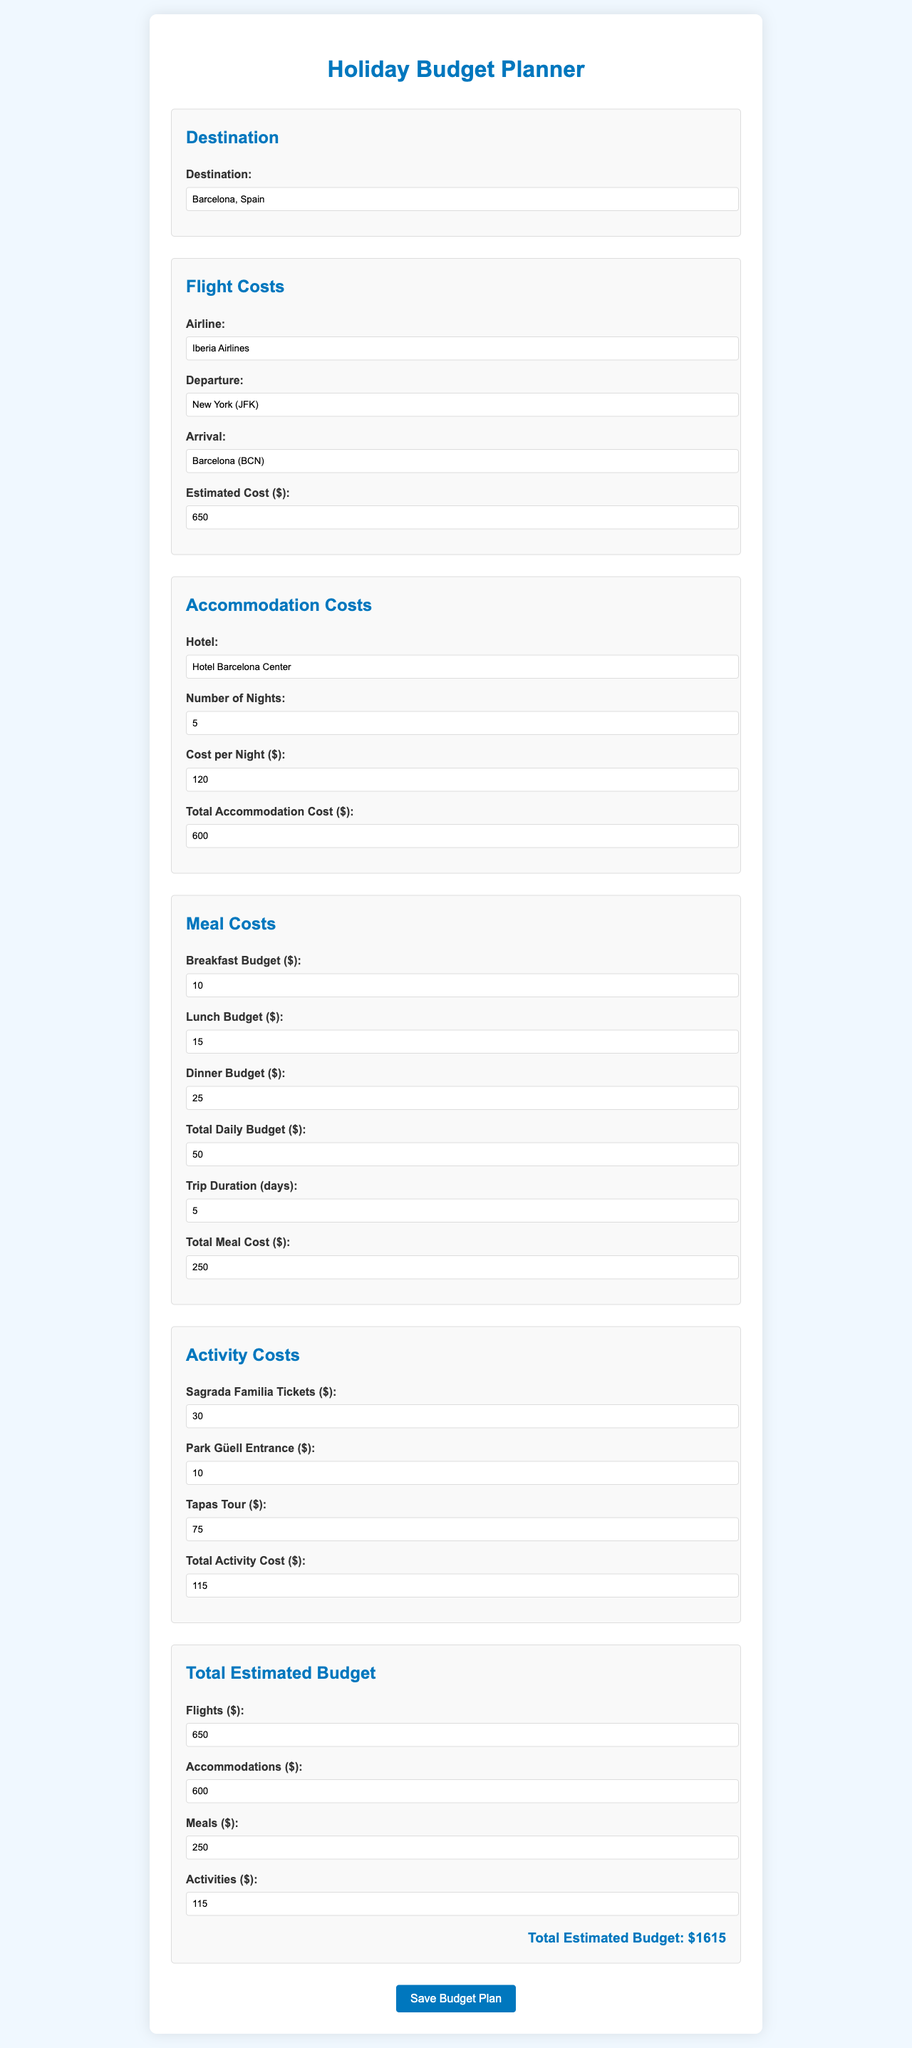What is the destination? The destination is specified in the form as Barcelona, Spain.
Answer: Barcelona, Spain What is the estimated flight cost? The estimated cost for flights is provided in the document, which is $650.
Answer: $650 How many nights will the accommodation be booked for? The document states that the number of nights for the accommodation is 5.
Answer: 5 What is the total meal cost? The total meal cost is calculated based on the provided budget and is $250.
Answer: $250 What are the activities planned? The activities planned include visiting Sagrada Familia, Park Güell, and a Tapas Tour.
Answer: Sagrada Familia, Park Güell, Tapas Tour What is the total estimated budget? The total estimated budget combines all costs and is mentioned as $1615.
Answer: $1615 How much does one night at the hotel cost? The cost per night for the hotel is stated to be $120.
Answer: $120 Which airline will be used for the flights? The document indicates that the airline is Iberia Airlines.
Answer: Iberia Airlines What is the daily budget for meals? The total daily budget for meals is stated as $50.
Answer: $50 What is the total cost for activities? The total cost allocated for activities is $115.
Answer: $115 